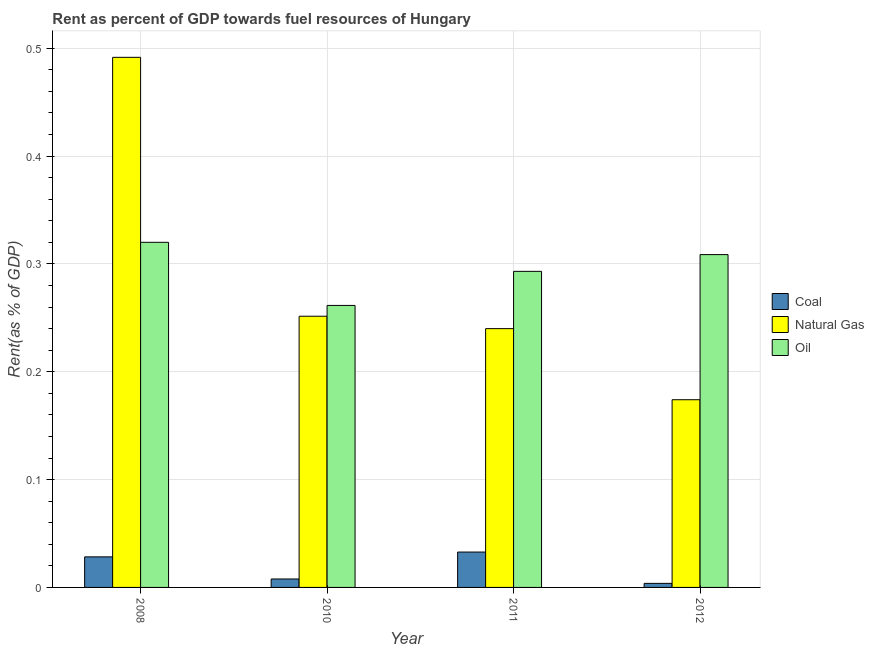How many groups of bars are there?
Make the answer very short. 4. Are the number of bars on each tick of the X-axis equal?
Provide a succinct answer. Yes. How many bars are there on the 1st tick from the left?
Make the answer very short. 3. How many bars are there on the 4th tick from the right?
Make the answer very short. 3. In how many cases, is the number of bars for a given year not equal to the number of legend labels?
Offer a terse response. 0. What is the rent towards natural gas in 2012?
Your response must be concise. 0.17. Across all years, what is the maximum rent towards natural gas?
Your answer should be compact. 0.49. Across all years, what is the minimum rent towards natural gas?
Keep it short and to the point. 0.17. In which year was the rent towards natural gas maximum?
Your answer should be very brief. 2008. In which year was the rent towards oil minimum?
Offer a terse response. 2010. What is the total rent towards oil in the graph?
Keep it short and to the point. 1.18. What is the difference between the rent towards coal in 2010 and that in 2012?
Keep it short and to the point. 0. What is the difference between the rent towards coal in 2011 and the rent towards oil in 2012?
Your answer should be very brief. 0.03. What is the average rent towards natural gas per year?
Offer a very short reply. 0.29. In how many years, is the rent towards coal greater than 0.06 %?
Keep it short and to the point. 0. What is the ratio of the rent towards natural gas in 2008 to that in 2010?
Your answer should be very brief. 1.95. Is the rent towards natural gas in 2008 less than that in 2011?
Your response must be concise. No. What is the difference between the highest and the second highest rent towards oil?
Offer a very short reply. 0.01. What is the difference between the highest and the lowest rent towards oil?
Your response must be concise. 0.06. What does the 3rd bar from the left in 2008 represents?
Offer a terse response. Oil. What does the 1st bar from the right in 2012 represents?
Give a very brief answer. Oil. How many bars are there?
Your answer should be compact. 12. Are all the bars in the graph horizontal?
Your answer should be compact. No. Are the values on the major ticks of Y-axis written in scientific E-notation?
Your response must be concise. No. Does the graph contain any zero values?
Provide a succinct answer. No. What is the title of the graph?
Make the answer very short. Rent as percent of GDP towards fuel resources of Hungary. What is the label or title of the Y-axis?
Keep it short and to the point. Rent(as % of GDP). What is the Rent(as % of GDP) in Coal in 2008?
Your answer should be compact. 0.03. What is the Rent(as % of GDP) of Natural Gas in 2008?
Provide a short and direct response. 0.49. What is the Rent(as % of GDP) of Oil in 2008?
Your answer should be very brief. 0.32. What is the Rent(as % of GDP) of Coal in 2010?
Make the answer very short. 0.01. What is the Rent(as % of GDP) of Natural Gas in 2010?
Your answer should be compact. 0.25. What is the Rent(as % of GDP) of Oil in 2010?
Provide a succinct answer. 0.26. What is the Rent(as % of GDP) of Coal in 2011?
Give a very brief answer. 0.03. What is the Rent(as % of GDP) of Natural Gas in 2011?
Offer a terse response. 0.24. What is the Rent(as % of GDP) in Oil in 2011?
Provide a succinct answer. 0.29. What is the Rent(as % of GDP) in Coal in 2012?
Make the answer very short. 0. What is the Rent(as % of GDP) in Natural Gas in 2012?
Your answer should be very brief. 0.17. What is the Rent(as % of GDP) of Oil in 2012?
Provide a short and direct response. 0.31. Across all years, what is the maximum Rent(as % of GDP) of Coal?
Provide a succinct answer. 0.03. Across all years, what is the maximum Rent(as % of GDP) in Natural Gas?
Offer a very short reply. 0.49. Across all years, what is the maximum Rent(as % of GDP) of Oil?
Your answer should be compact. 0.32. Across all years, what is the minimum Rent(as % of GDP) in Coal?
Provide a succinct answer. 0. Across all years, what is the minimum Rent(as % of GDP) of Natural Gas?
Provide a succinct answer. 0.17. Across all years, what is the minimum Rent(as % of GDP) of Oil?
Keep it short and to the point. 0.26. What is the total Rent(as % of GDP) in Coal in the graph?
Offer a terse response. 0.07. What is the total Rent(as % of GDP) of Natural Gas in the graph?
Offer a terse response. 1.16. What is the total Rent(as % of GDP) in Oil in the graph?
Make the answer very short. 1.18. What is the difference between the Rent(as % of GDP) of Coal in 2008 and that in 2010?
Offer a very short reply. 0.02. What is the difference between the Rent(as % of GDP) in Natural Gas in 2008 and that in 2010?
Your answer should be very brief. 0.24. What is the difference between the Rent(as % of GDP) of Oil in 2008 and that in 2010?
Keep it short and to the point. 0.06. What is the difference between the Rent(as % of GDP) of Coal in 2008 and that in 2011?
Keep it short and to the point. -0. What is the difference between the Rent(as % of GDP) of Natural Gas in 2008 and that in 2011?
Provide a short and direct response. 0.25. What is the difference between the Rent(as % of GDP) of Oil in 2008 and that in 2011?
Offer a terse response. 0.03. What is the difference between the Rent(as % of GDP) of Coal in 2008 and that in 2012?
Make the answer very short. 0.02. What is the difference between the Rent(as % of GDP) in Natural Gas in 2008 and that in 2012?
Offer a very short reply. 0.32. What is the difference between the Rent(as % of GDP) in Oil in 2008 and that in 2012?
Your answer should be very brief. 0.01. What is the difference between the Rent(as % of GDP) in Coal in 2010 and that in 2011?
Keep it short and to the point. -0.03. What is the difference between the Rent(as % of GDP) of Natural Gas in 2010 and that in 2011?
Give a very brief answer. 0.01. What is the difference between the Rent(as % of GDP) of Oil in 2010 and that in 2011?
Provide a succinct answer. -0.03. What is the difference between the Rent(as % of GDP) of Coal in 2010 and that in 2012?
Keep it short and to the point. 0. What is the difference between the Rent(as % of GDP) in Natural Gas in 2010 and that in 2012?
Offer a very short reply. 0.08. What is the difference between the Rent(as % of GDP) of Oil in 2010 and that in 2012?
Your answer should be compact. -0.05. What is the difference between the Rent(as % of GDP) of Coal in 2011 and that in 2012?
Your answer should be compact. 0.03. What is the difference between the Rent(as % of GDP) in Natural Gas in 2011 and that in 2012?
Your response must be concise. 0.07. What is the difference between the Rent(as % of GDP) of Oil in 2011 and that in 2012?
Offer a very short reply. -0.02. What is the difference between the Rent(as % of GDP) in Coal in 2008 and the Rent(as % of GDP) in Natural Gas in 2010?
Your answer should be compact. -0.22. What is the difference between the Rent(as % of GDP) in Coal in 2008 and the Rent(as % of GDP) in Oil in 2010?
Keep it short and to the point. -0.23. What is the difference between the Rent(as % of GDP) of Natural Gas in 2008 and the Rent(as % of GDP) of Oil in 2010?
Give a very brief answer. 0.23. What is the difference between the Rent(as % of GDP) in Coal in 2008 and the Rent(as % of GDP) in Natural Gas in 2011?
Offer a very short reply. -0.21. What is the difference between the Rent(as % of GDP) of Coal in 2008 and the Rent(as % of GDP) of Oil in 2011?
Your response must be concise. -0.26. What is the difference between the Rent(as % of GDP) of Natural Gas in 2008 and the Rent(as % of GDP) of Oil in 2011?
Offer a very short reply. 0.2. What is the difference between the Rent(as % of GDP) of Coal in 2008 and the Rent(as % of GDP) of Natural Gas in 2012?
Keep it short and to the point. -0.15. What is the difference between the Rent(as % of GDP) of Coal in 2008 and the Rent(as % of GDP) of Oil in 2012?
Give a very brief answer. -0.28. What is the difference between the Rent(as % of GDP) in Natural Gas in 2008 and the Rent(as % of GDP) in Oil in 2012?
Your answer should be compact. 0.18. What is the difference between the Rent(as % of GDP) in Coal in 2010 and the Rent(as % of GDP) in Natural Gas in 2011?
Your answer should be compact. -0.23. What is the difference between the Rent(as % of GDP) in Coal in 2010 and the Rent(as % of GDP) in Oil in 2011?
Offer a very short reply. -0.29. What is the difference between the Rent(as % of GDP) of Natural Gas in 2010 and the Rent(as % of GDP) of Oil in 2011?
Keep it short and to the point. -0.04. What is the difference between the Rent(as % of GDP) of Coal in 2010 and the Rent(as % of GDP) of Natural Gas in 2012?
Keep it short and to the point. -0.17. What is the difference between the Rent(as % of GDP) of Coal in 2010 and the Rent(as % of GDP) of Oil in 2012?
Your answer should be very brief. -0.3. What is the difference between the Rent(as % of GDP) of Natural Gas in 2010 and the Rent(as % of GDP) of Oil in 2012?
Offer a very short reply. -0.06. What is the difference between the Rent(as % of GDP) of Coal in 2011 and the Rent(as % of GDP) of Natural Gas in 2012?
Provide a short and direct response. -0.14. What is the difference between the Rent(as % of GDP) in Coal in 2011 and the Rent(as % of GDP) in Oil in 2012?
Offer a terse response. -0.28. What is the difference between the Rent(as % of GDP) in Natural Gas in 2011 and the Rent(as % of GDP) in Oil in 2012?
Ensure brevity in your answer.  -0.07. What is the average Rent(as % of GDP) of Coal per year?
Provide a short and direct response. 0.02. What is the average Rent(as % of GDP) of Natural Gas per year?
Your answer should be compact. 0.29. What is the average Rent(as % of GDP) of Oil per year?
Ensure brevity in your answer.  0.3. In the year 2008, what is the difference between the Rent(as % of GDP) in Coal and Rent(as % of GDP) in Natural Gas?
Provide a short and direct response. -0.46. In the year 2008, what is the difference between the Rent(as % of GDP) of Coal and Rent(as % of GDP) of Oil?
Offer a very short reply. -0.29. In the year 2008, what is the difference between the Rent(as % of GDP) in Natural Gas and Rent(as % of GDP) in Oil?
Make the answer very short. 0.17. In the year 2010, what is the difference between the Rent(as % of GDP) of Coal and Rent(as % of GDP) of Natural Gas?
Make the answer very short. -0.24. In the year 2010, what is the difference between the Rent(as % of GDP) in Coal and Rent(as % of GDP) in Oil?
Offer a very short reply. -0.25. In the year 2010, what is the difference between the Rent(as % of GDP) of Natural Gas and Rent(as % of GDP) of Oil?
Give a very brief answer. -0.01. In the year 2011, what is the difference between the Rent(as % of GDP) in Coal and Rent(as % of GDP) in Natural Gas?
Make the answer very short. -0.21. In the year 2011, what is the difference between the Rent(as % of GDP) of Coal and Rent(as % of GDP) of Oil?
Keep it short and to the point. -0.26. In the year 2011, what is the difference between the Rent(as % of GDP) in Natural Gas and Rent(as % of GDP) in Oil?
Provide a short and direct response. -0.05. In the year 2012, what is the difference between the Rent(as % of GDP) in Coal and Rent(as % of GDP) in Natural Gas?
Give a very brief answer. -0.17. In the year 2012, what is the difference between the Rent(as % of GDP) of Coal and Rent(as % of GDP) of Oil?
Provide a short and direct response. -0.3. In the year 2012, what is the difference between the Rent(as % of GDP) in Natural Gas and Rent(as % of GDP) in Oil?
Your answer should be very brief. -0.13. What is the ratio of the Rent(as % of GDP) in Coal in 2008 to that in 2010?
Ensure brevity in your answer.  3.61. What is the ratio of the Rent(as % of GDP) in Natural Gas in 2008 to that in 2010?
Keep it short and to the point. 1.95. What is the ratio of the Rent(as % of GDP) in Oil in 2008 to that in 2010?
Your response must be concise. 1.22. What is the ratio of the Rent(as % of GDP) in Coal in 2008 to that in 2011?
Your answer should be very brief. 0.86. What is the ratio of the Rent(as % of GDP) of Natural Gas in 2008 to that in 2011?
Your response must be concise. 2.05. What is the ratio of the Rent(as % of GDP) of Oil in 2008 to that in 2011?
Ensure brevity in your answer.  1.09. What is the ratio of the Rent(as % of GDP) of Coal in 2008 to that in 2012?
Offer a terse response. 7.53. What is the ratio of the Rent(as % of GDP) in Natural Gas in 2008 to that in 2012?
Your response must be concise. 2.82. What is the ratio of the Rent(as % of GDP) in Coal in 2010 to that in 2011?
Ensure brevity in your answer.  0.24. What is the ratio of the Rent(as % of GDP) in Natural Gas in 2010 to that in 2011?
Your answer should be very brief. 1.05. What is the ratio of the Rent(as % of GDP) of Oil in 2010 to that in 2011?
Your answer should be very brief. 0.89. What is the ratio of the Rent(as % of GDP) in Coal in 2010 to that in 2012?
Provide a succinct answer. 2.08. What is the ratio of the Rent(as % of GDP) in Natural Gas in 2010 to that in 2012?
Your answer should be very brief. 1.44. What is the ratio of the Rent(as % of GDP) of Oil in 2010 to that in 2012?
Your answer should be very brief. 0.85. What is the ratio of the Rent(as % of GDP) of Coal in 2011 to that in 2012?
Provide a short and direct response. 8.72. What is the ratio of the Rent(as % of GDP) in Natural Gas in 2011 to that in 2012?
Your answer should be compact. 1.38. What is the ratio of the Rent(as % of GDP) of Oil in 2011 to that in 2012?
Offer a very short reply. 0.95. What is the difference between the highest and the second highest Rent(as % of GDP) of Coal?
Provide a succinct answer. 0. What is the difference between the highest and the second highest Rent(as % of GDP) in Natural Gas?
Ensure brevity in your answer.  0.24. What is the difference between the highest and the second highest Rent(as % of GDP) of Oil?
Give a very brief answer. 0.01. What is the difference between the highest and the lowest Rent(as % of GDP) in Coal?
Your response must be concise. 0.03. What is the difference between the highest and the lowest Rent(as % of GDP) in Natural Gas?
Make the answer very short. 0.32. What is the difference between the highest and the lowest Rent(as % of GDP) in Oil?
Make the answer very short. 0.06. 